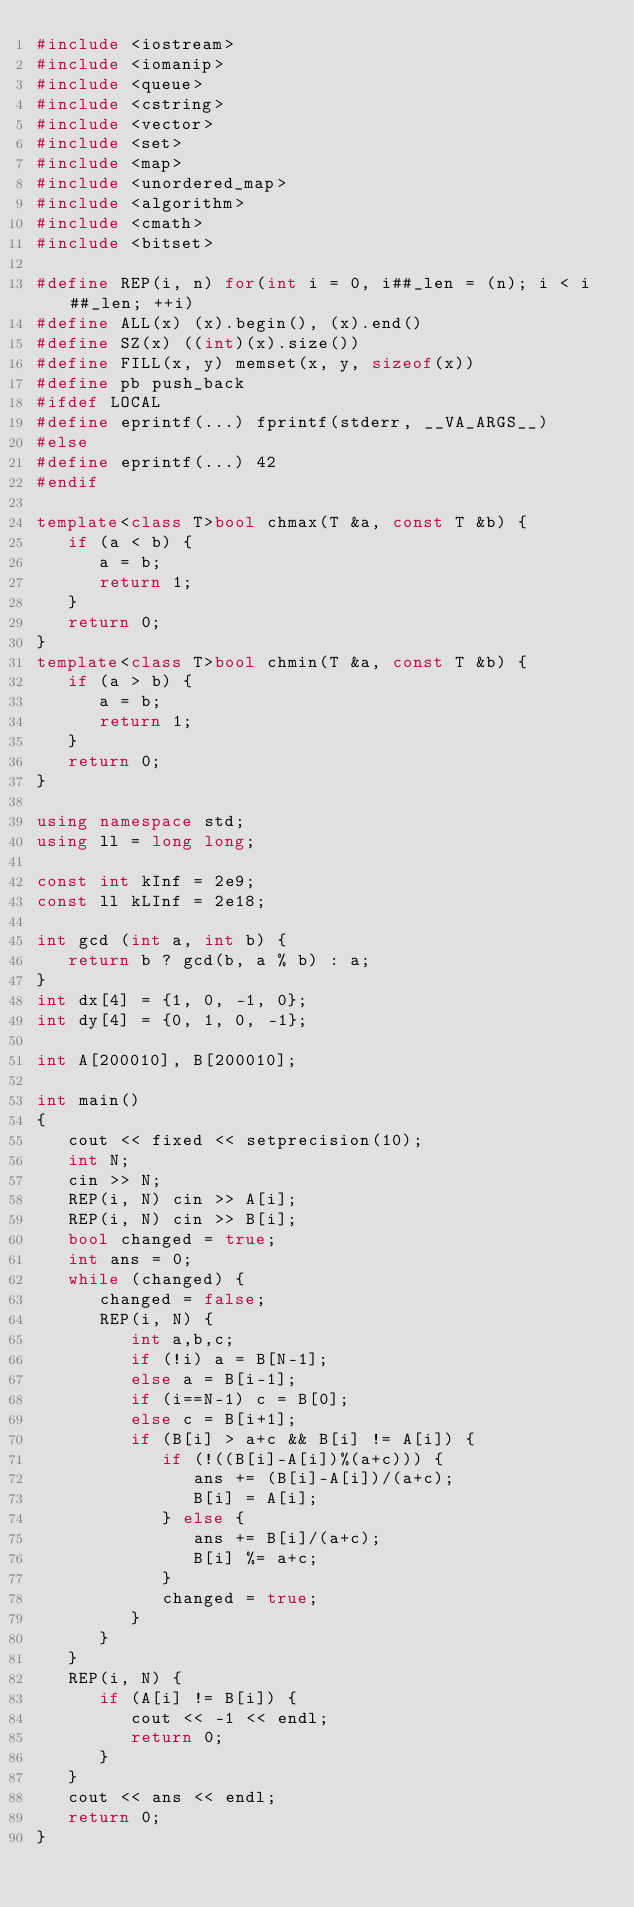<code> <loc_0><loc_0><loc_500><loc_500><_C++_>#include <iostream>
#include <iomanip>
#include <queue>
#include <cstring>
#include <vector>
#include <set>
#include <map>
#include <unordered_map>
#include <algorithm>
#include <cmath>
#include <bitset>

#define REP(i, n) for(int i = 0, i##_len = (n); i < i##_len; ++i)
#define ALL(x) (x).begin(), (x).end()
#define SZ(x) ((int)(x).size())
#define FILL(x, y) memset(x, y, sizeof(x))
#define pb push_back
#ifdef LOCAL
#define eprintf(...) fprintf(stderr, __VA_ARGS__)
#else
#define eprintf(...) 42
#endif

template<class T>bool chmax(T &a, const T &b) {
   if (a < b) {
      a = b;
      return 1;
   }
   return 0;
}
template<class T>bool chmin(T &a, const T &b) {
   if (a > b) {
      a = b;
      return 1;
   }
   return 0;
}

using namespace std;
using ll = long long;

const int kInf = 2e9;
const ll kLInf = 2e18;

int gcd (int a, int b) {
   return b ? gcd(b, a % b) : a;
}
int dx[4] = {1, 0, -1, 0};
int dy[4] = {0, 1, 0, -1};

int A[200010], B[200010];

int main()
{
   cout << fixed << setprecision(10);
   int N;
   cin >> N;
   REP(i, N) cin >> A[i];
   REP(i, N) cin >> B[i];
   bool changed = true;
   int ans = 0;
   while (changed) {
      changed = false;
      REP(i, N) {
         int a,b,c;
         if (!i) a = B[N-1];
         else a = B[i-1];
         if (i==N-1) c = B[0];
         else c = B[i+1];
         if (B[i] > a+c && B[i] != A[i]) {
            if (!((B[i]-A[i])%(a+c))) {
               ans += (B[i]-A[i])/(a+c);
               B[i] = A[i];
            } else {
               ans += B[i]/(a+c);
               B[i] %= a+c;
            }
            changed = true;
         }
      }
   }
   REP(i, N) {
      if (A[i] != B[i]) {
         cout << -1 << endl;
         return 0;
      }
   }
   cout << ans << endl;
   return 0;
}

</code> 